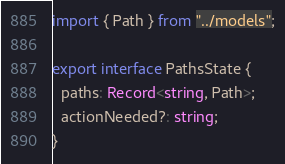<code> <loc_0><loc_0><loc_500><loc_500><_TypeScript_>import { Path } from "../models";

export interface PathsState {
  paths: Record<string, Path>;
  actionNeeded?: string;
}
</code> 